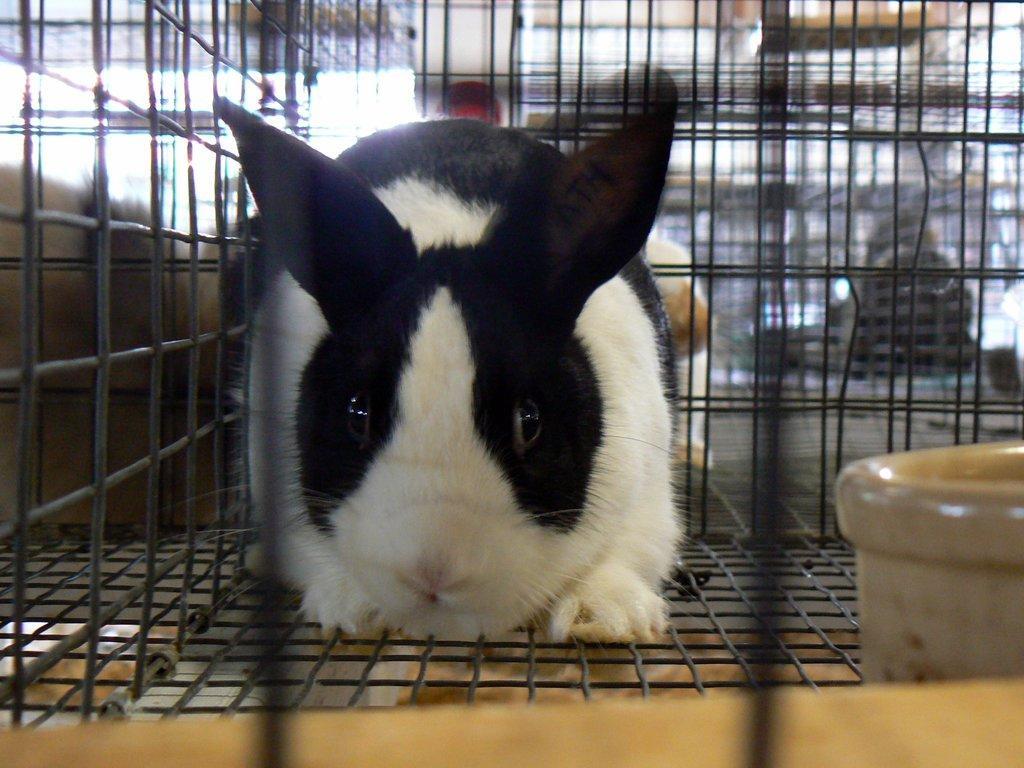How would you summarize this image in a sentence or two? In this image there is a rabbit in the cage. Beside the rabbit there is an object. 